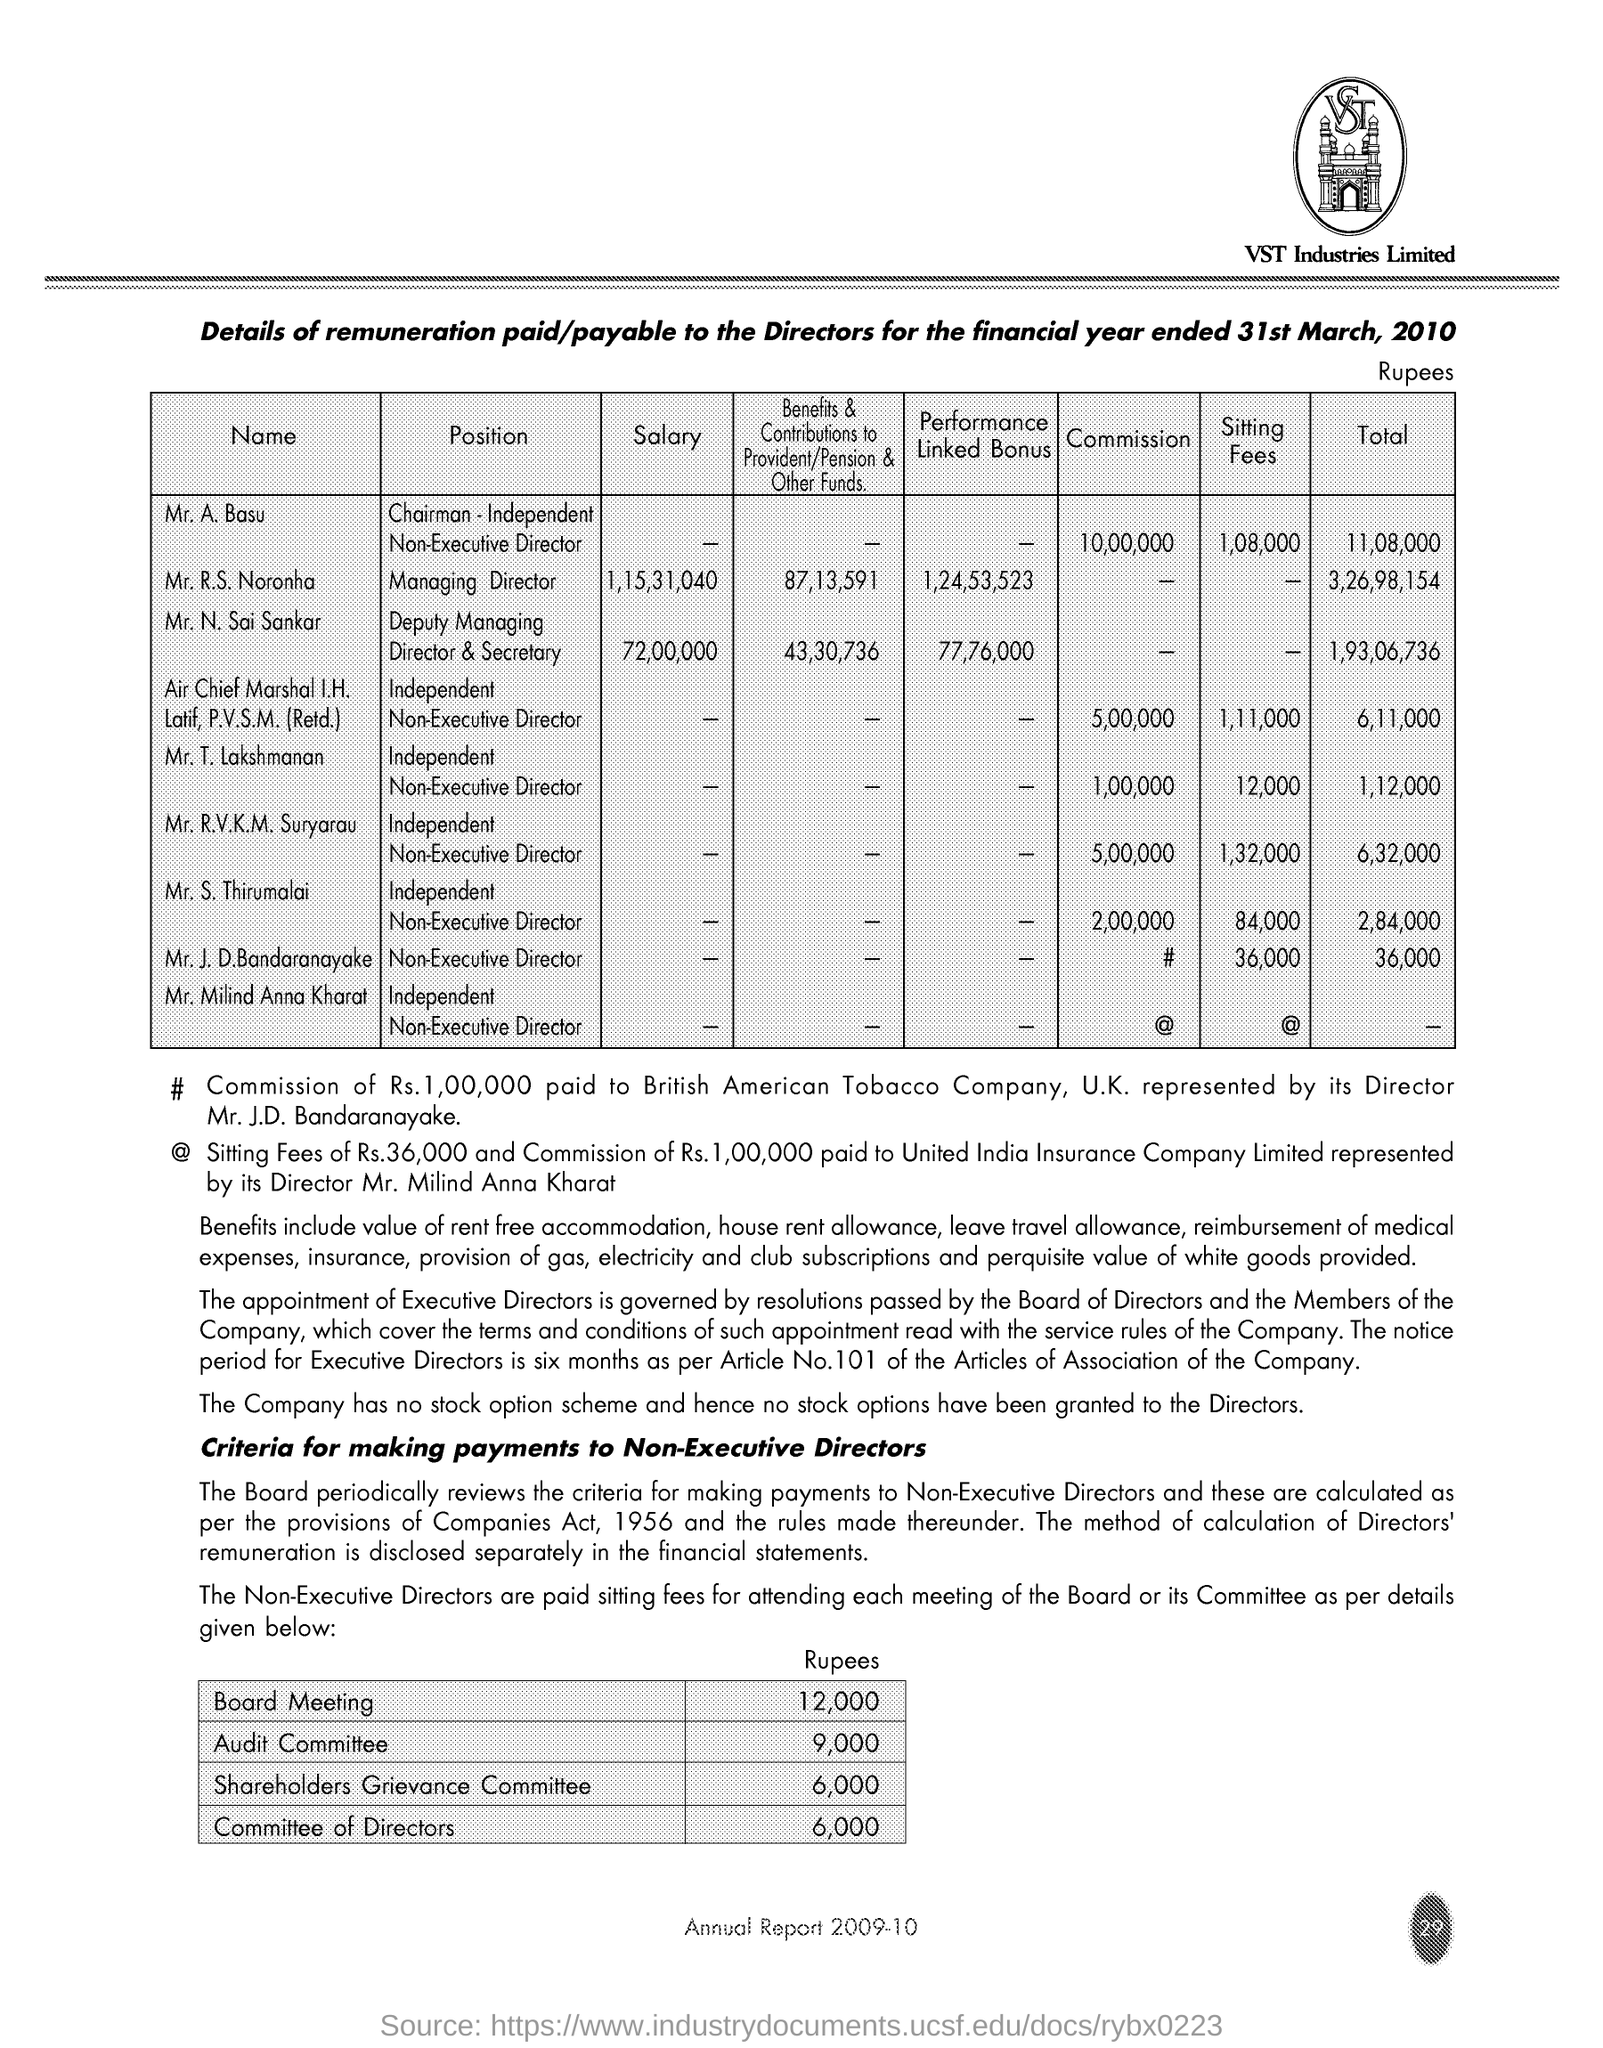Identify some key points in this picture. The setting fees for Mr. T. Lakshmanan is 12,000. 